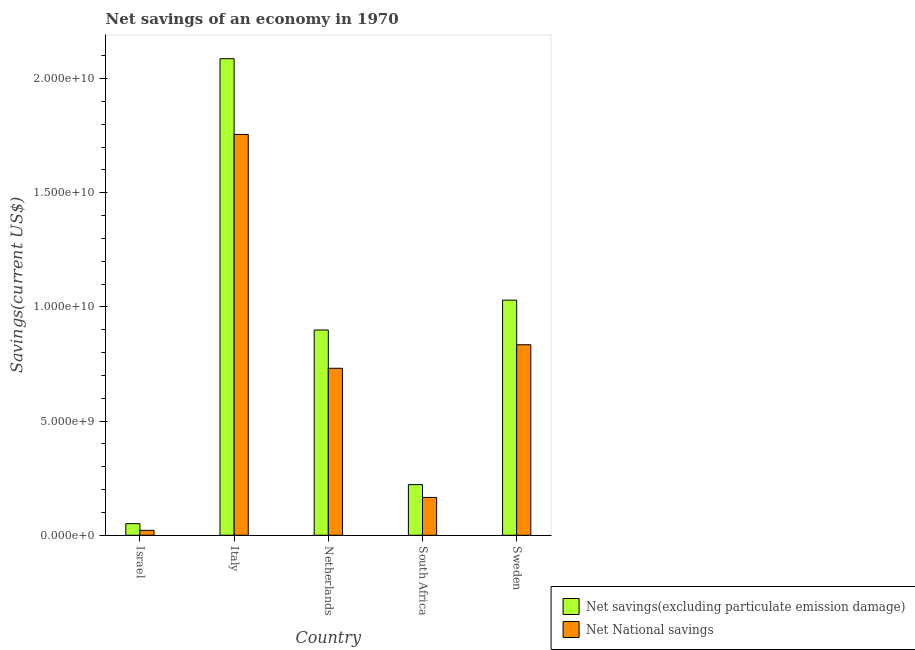How many different coloured bars are there?
Make the answer very short. 2. Are the number of bars per tick equal to the number of legend labels?
Your answer should be very brief. Yes. Are the number of bars on each tick of the X-axis equal?
Make the answer very short. Yes. How many bars are there on the 2nd tick from the left?
Your answer should be very brief. 2. What is the label of the 3rd group of bars from the left?
Offer a very short reply. Netherlands. What is the net national savings in Netherlands?
Provide a succinct answer. 7.31e+09. Across all countries, what is the maximum net national savings?
Your answer should be compact. 1.76e+1. Across all countries, what is the minimum net savings(excluding particulate emission damage)?
Offer a very short reply. 5.08e+08. What is the total net savings(excluding particulate emission damage) in the graph?
Offer a very short reply. 4.29e+1. What is the difference between the net national savings in South Africa and that in Sweden?
Ensure brevity in your answer.  -6.69e+09. What is the difference between the net savings(excluding particulate emission damage) in Sweden and the net national savings in South Africa?
Give a very brief answer. 8.64e+09. What is the average net savings(excluding particulate emission damage) per country?
Keep it short and to the point. 8.58e+09. What is the difference between the net savings(excluding particulate emission damage) and net national savings in South Africa?
Your answer should be compact. 5.62e+08. What is the ratio of the net savings(excluding particulate emission damage) in Israel to that in Netherlands?
Ensure brevity in your answer.  0.06. Is the difference between the net national savings in Israel and Sweden greater than the difference between the net savings(excluding particulate emission damage) in Israel and Sweden?
Your response must be concise. Yes. What is the difference between the highest and the second highest net savings(excluding particulate emission damage)?
Keep it short and to the point. 1.06e+1. What is the difference between the highest and the lowest net national savings?
Your response must be concise. 1.73e+1. Is the sum of the net savings(excluding particulate emission damage) in Italy and Netherlands greater than the maximum net national savings across all countries?
Ensure brevity in your answer.  Yes. What does the 2nd bar from the left in Italy represents?
Ensure brevity in your answer.  Net National savings. What does the 2nd bar from the right in South Africa represents?
Give a very brief answer. Net savings(excluding particulate emission damage). Are all the bars in the graph horizontal?
Provide a short and direct response. No. What is the difference between two consecutive major ticks on the Y-axis?
Give a very brief answer. 5.00e+09. Does the graph contain any zero values?
Keep it short and to the point. No. Does the graph contain grids?
Offer a terse response. No. How many legend labels are there?
Provide a succinct answer. 2. How are the legend labels stacked?
Ensure brevity in your answer.  Vertical. What is the title of the graph?
Ensure brevity in your answer.  Net savings of an economy in 1970. What is the label or title of the X-axis?
Make the answer very short. Country. What is the label or title of the Y-axis?
Your answer should be very brief. Savings(current US$). What is the Savings(current US$) of Net savings(excluding particulate emission damage) in Israel?
Ensure brevity in your answer.  5.08e+08. What is the Savings(current US$) of Net National savings in Israel?
Offer a very short reply. 2.15e+08. What is the Savings(current US$) of Net savings(excluding particulate emission damage) in Italy?
Offer a terse response. 2.09e+1. What is the Savings(current US$) in Net National savings in Italy?
Ensure brevity in your answer.  1.76e+1. What is the Savings(current US$) of Net savings(excluding particulate emission damage) in Netherlands?
Offer a terse response. 8.99e+09. What is the Savings(current US$) of Net National savings in Netherlands?
Provide a succinct answer. 7.31e+09. What is the Savings(current US$) of Net savings(excluding particulate emission damage) in South Africa?
Offer a terse response. 2.22e+09. What is the Savings(current US$) in Net National savings in South Africa?
Offer a very short reply. 1.66e+09. What is the Savings(current US$) of Net savings(excluding particulate emission damage) in Sweden?
Offer a very short reply. 1.03e+1. What is the Savings(current US$) of Net National savings in Sweden?
Provide a short and direct response. 8.34e+09. Across all countries, what is the maximum Savings(current US$) in Net savings(excluding particulate emission damage)?
Offer a terse response. 2.09e+1. Across all countries, what is the maximum Savings(current US$) of Net National savings?
Keep it short and to the point. 1.76e+1. Across all countries, what is the minimum Savings(current US$) in Net savings(excluding particulate emission damage)?
Provide a short and direct response. 5.08e+08. Across all countries, what is the minimum Savings(current US$) in Net National savings?
Keep it short and to the point. 2.15e+08. What is the total Savings(current US$) in Net savings(excluding particulate emission damage) in the graph?
Keep it short and to the point. 4.29e+1. What is the total Savings(current US$) in Net National savings in the graph?
Offer a terse response. 3.51e+1. What is the difference between the Savings(current US$) in Net savings(excluding particulate emission damage) in Israel and that in Italy?
Give a very brief answer. -2.04e+1. What is the difference between the Savings(current US$) of Net National savings in Israel and that in Italy?
Offer a terse response. -1.73e+1. What is the difference between the Savings(current US$) of Net savings(excluding particulate emission damage) in Israel and that in Netherlands?
Keep it short and to the point. -8.48e+09. What is the difference between the Savings(current US$) of Net National savings in Israel and that in Netherlands?
Keep it short and to the point. -7.10e+09. What is the difference between the Savings(current US$) in Net savings(excluding particulate emission damage) in Israel and that in South Africa?
Ensure brevity in your answer.  -1.71e+09. What is the difference between the Savings(current US$) in Net National savings in Israel and that in South Africa?
Your answer should be very brief. -1.44e+09. What is the difference between the Savings(current US$) of Net savings(excluding particulate emission damage) in Israel and that in Sweden?
Provide a succinct answer. -9.79e+09. What is the difference between the Savings(current US$) in Net National savings in Israel and that in Sweden?
Keep it short and to the point. -8.13e+09. What is the difference between the Savings(current US$) of Net savings(excluding particulate emission damage) in Italy and that in Netherlands?
Ensure brevity in your answer.  1.19e+1. What is the difference between the Savings(current US$) in Net National savings in Italy and that in Netherlands?
Ensure brevity in your answer.  1.02e+1. What is the difference between the Savings(current US$) in Net savings(excluding particulate emission damage) in Italy and that in South Africa?
Your response must be concise. 1.87e+1. What is the difference between the Savings(current US$) in Net National savings in Italy and that in South Africa?
Ensure brevity in your answer.  1.59e+1. What is the difference between the Savings(current US$) in Net savings(excluding particulate emission damage) in Italy and that in Sweden?
Offer a terse response. 1.06e+1. What is the difference between the Savings(current US$) in Net National savings in Italy and that in Sweden?
Offer a very short reply. 9.21e+09. What is the difference between the Savings(current US$) in Net savings(excluding particulate emission damage) in Netherlands and that in South Africa?
Give a very brief answer. 6.77e+09. What is the difference between the Savings(current US$) in Net National savings in Netherlands and that in South Africa?
Provide a succinct answer. 5.66e+09. What is the difference between the Savings(current US$) of Net savings(excluding particulate emission damage) in Netherlands and that in Sweden?
Keep it short and to the point. -1.31e+09. What is the difference between the Savings(current US$) in Net National savings in Netherlands and that in Sweden?
Make the answer very short. -1.03e+09. What is the difference between the Savings(current US$) of Net savings(excluding particulate emission damage) in South Africa and that in Sweden?
Offer a very short reply. -8.08e+09. What is the difference between the Savings(current US$) in Net National savings in South Africa and that in Sweden?
Ensure brevity in your answer.  -6.69e+09. What is the difference between the Savings(current US$) of Net savings(excluding particulate emission damage) in Israel and the Savings(current US$) of Net National savings in Italy?
Provide a short and direct response. -1.70e+1. What is the difference between the Savings(current US$) of Net savings(excluding particulate emission damage) in Israel and the Savings(current US$) of Net National savings in Netherlands?
Keep it short and to the point. -6.80e+09. What is the difference between the Savings(current US$) in Net savings(excluding particulate emission damage) in Israel and the Savings(current US$) in Net National savings in South Africa?
Provide a short and direct response. -1.15e+09. What is the difference between the Savings(current US$) in Net savings(excluding particulate emission damage) in Israel and the Savings(current US$) in Net National savings in Sweden?
Give a very brief answer. -7.83e+09. What is the difference between the Savings(current US$) of Net savings(excluding particulate emission damage) in Italy and the Savings(current US$) of Net National savings in Netherlands?
Provide a short and direct response. 1.36e+1. What is the difference between the Savings(current US$) of Net savings(excluding particulate emission damage) in Italy and the Savings(current US$) of Net National savings in South Africa?
Your answer should be compact. 1.92e+1. What is the difference between the Savings(current US$) in Net savings(excluding particulate emission damage) in Italy and the Savings(current US$) in Net National savings in Sweden?
Provide a short and direct response. 1.25e+1. What is the difference between the Savings(current US$) in Net savings(excluding particulate emission damage) in Netherlands and the Savings(current US$) in Net National savings in South Africa?
Make the answer very short. 7.33e+09. What is the difference between the Savings(current US$) in Net savings(excluding particulate emission damage) in Netherlands and the Savings(current US$) in Net National savings in Sweden?
Your answer should be very brief. 6.46e+08. What is the difference between the Savings(current US$) of Net savings(excluding particulate emission damage) in South Africa and the Savings(current US$) of Net National savings in Sweden?
Provide a succinct answer. -6.12e+09. What is the average Savings(current US$) of Net savings(excluding particulate emission damage) per country?
Provide a succinct answer. 8.58e+09. What is the average Savings(current US$) in Net National savings per country?
Offer a very short reply. 7.02e+09. What is the difference between the Savings(current US$) of Net savings(excluding particulate emission damage) and Savings(current US$) of Net National savings in Israel?
Provide a succinct answer. 2.93e+08. What is the difference between the Savings(current US$) of Net savings(excluding particulate emission damage) and Savings(current US$) of Net National savings in Italy?
Offer a very short reply. 3.32e+09. What is the difference between the Savings(current US$) in Net savings(excluding particulate emission damage) and Savings(current US$) in Net National savings in Netherlands?
Your response must be concise. 1.68e+09. What is the difference between the Savings(current US$) of Net savings(excluding particulate emission damage) and Savings(current US$) of Net National savings in South Africa?
Your answer should be very brief. 5.62e+08. What is the difference between the Savings(current US$) in Net savings(excluding particulate emission damage) and Savings(current US$) in Net National savings in Sweden?
Make the answer very short. 1.95e+09. What is the ratio of the Savings(current US$) of Net savings(excluding particulate emission damage) in Israel to that in Italy?
Make the answer very short. 0.02. What is the ratio of the Savings(current US$) in Net National savings in Israel to that in Italy?
Make the answer very short. 0.01. What is the ratio of the Savings(current US$) of Net savings(excluding particulate emission damage) in Israel to that in Netherlands?
Your response must be concise. 0.06. What is the ratio of the Savings(current US$) in Net National savings in Israel to that in Netherlands?
Your answer should be very brief. 0.03. What is the ratio of the Savings(current US$) in Net savings(excluding particulate emission damage) in Israel to that in South Africa?
Keep it short and to the point. 0.23. What is the ratio of the Savings(current US$) in Net National savings in Israel to that in South Africa?
Your answer should be compact. 0.13. What is the ratio of the Savings(current US$) of Net savings(excluding particulate emission damage) in Israel to that in Sweden?
Keep it short and to the point. 0.05. What is the ratio of the Savings(current US$) of Net National savings in Israel to that in Sweden?
Keep it short and to the point. 0.03. What is the ratio of the Savings(current US$) of Net savings(excluding particulate emission damage) in Italy to that in Netherlands?
Ensure brevity in your answer.  2.32. What is the ratio of the Savings(current US$) in Net National savings in Italy to that in Netherlands?
Give a very brief answer. 2.4. What is the ratio of the Savings(current US$) in Net savings(excluding particulate emission damage) in Italy to that in South Africa?
Give a very brief answer. 9.41. What is the ratio of the Savings(current US$) of Net National savings in Italy to that in South Africa?
Your answer should be compact. 10.6. What is the ratio of the Savings(current US$) of Net savings(excluding particulate emission damage) in Italy to that in Sweden?
Give a very brief answer. 2.03. What is the ratio of the Savings(current US$) of Net National savings in Italy to that in Sweden?
Keep it short and to the point. 2.1. What is the ratio of the Savings(current US$) in Net savings(excluding particulate emission damage) in Netherlands to that in South Africa?
Provide a succinct answer. 4.05. What is the ratio of the Savings(current US$) in Net National savings in Netherlands to that in South Africa?
Give a very brief answer. 4.42. What is the ratio of the Savings(current US$) of Net savings(excluding particulate emission damage) in Netherlands to that in Sweden?
Offer a terse response. 0.87. What is the ratio of the Savings(current US$) in Net National savings in Netherlands to that in Sweden?
Your answer should be compact. 0.88. What is the ratio of the Savings(current US$) of Net savings(excluding particulate emission damage) in South Africa to that in Sweden?
Ensure brevity in your answer.  0.22. What is the ratio of the Savings(current US$) in Net National savings in South Africa to that in Sweden?
Keep it short and to the point. 0.2. What is the difference between the highest and the second highest Savings(current US$) in Net savings(excluding particulate emission damage)?
Provide a succinct answer. 1.06e+1. What is the difference between the highest and the second highest Savings(current US$) of Net National savings?
Your response must be concise. 9.21e+09. What is the difference between the highest and the lowest Savings(current US$) in Net savings(excluding particulate emission damage)?
Your answer should be very brief. 2.04e+1. What is the difference between the highest and the lowest Savings(current US$) of Net National savings?
Give a very brief answer. 1.73e+1. 